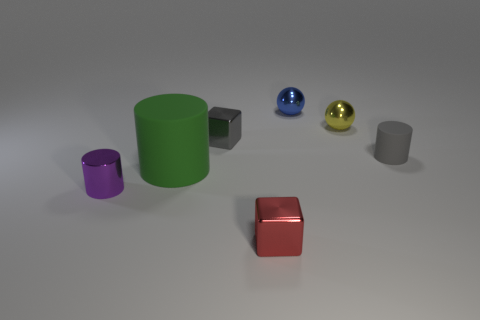Add 1 small blue things. How many objects exist? 8 Subtract all cubes. How many objects are left? 5 Add 1 red metal things. How many red metal things are left? 2 Add 5 gray objects. How many gray objects exist? 7 Subtract 0 cyan cylinders. How many objects are left? 7 Subtract all purple metallic cylinders. Subtract all tiny red metallic blocks. How many objects are left? 5 